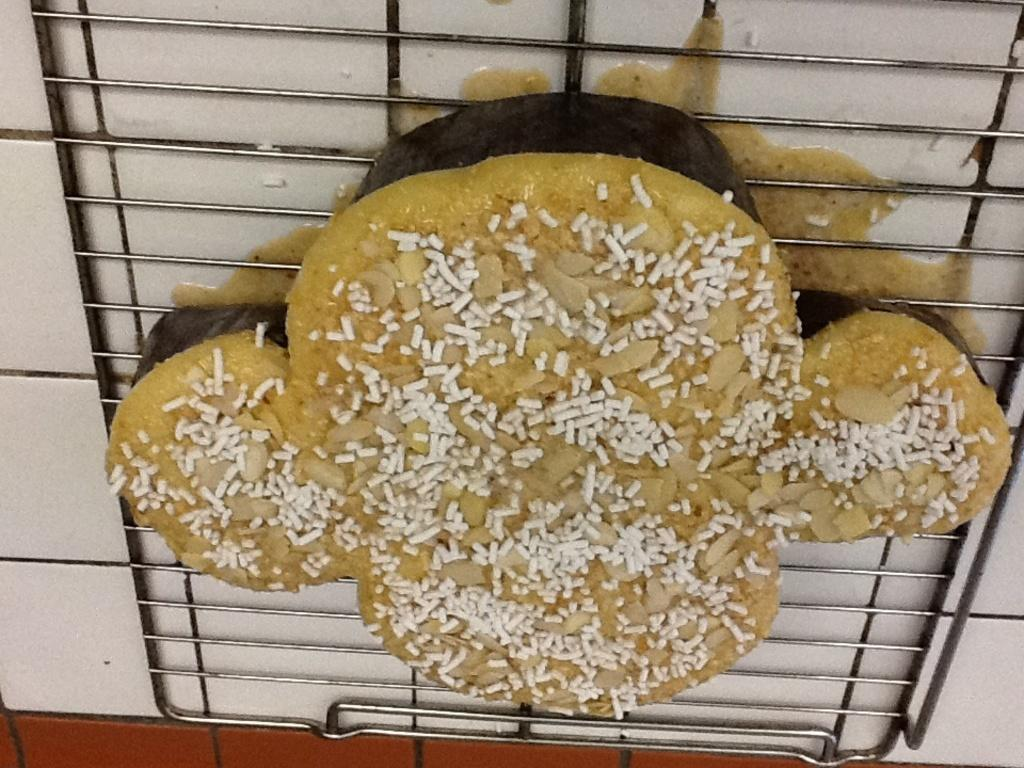What is being cooked or prepared in the image? There are food items on a grill in the image. Where is the grill located in the image? The grill is located in the center of the image. Is there a boat visible in the image? No, there is no boat present in the image. Can you see a nest in the image? No, there is no nest present in the image. 